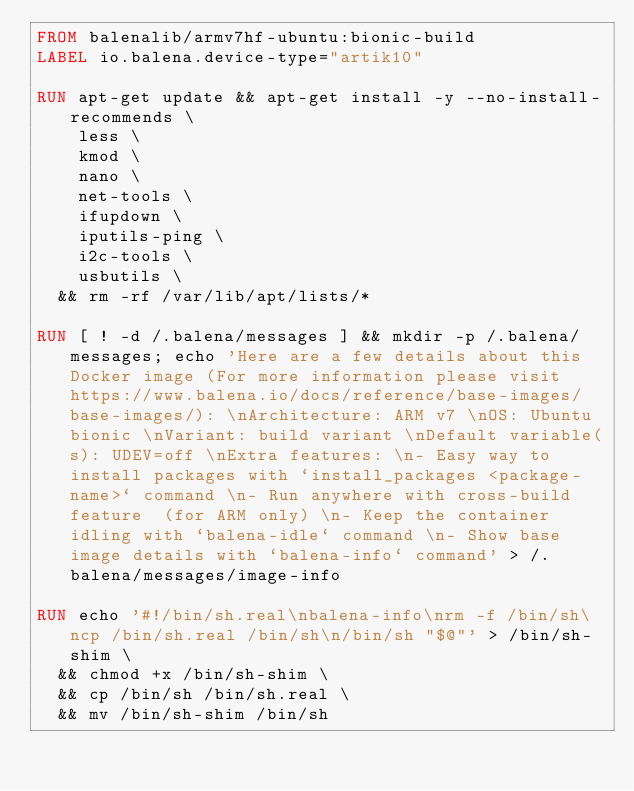Convert code to text. <code><loc_0><loc_0><loc_500><loc_500><_Dockerfile_>FROM balenalib/armv7hf-ubuntu:bionic-build
LABEL io.balena.device-type="artik10"

RUN apt-get update && apt-get install -y --no-install-recommends \
		less \
		kmod \
		nano \
		net-tools \
		ifupdown \
		iputils-ping \
		i2c-tools \
		usbutils \
	&& rm -rf /var/lib/apt/lists/*

RUN [ ! -d /.balena/messages ] && mkdir -p /.balena/messages; echo 'Here are a few details about this Docker image (For more information please visit https://www.balena.io/docs/reference/base-images/base-images/): \nArchitecture: ARM v7 \nOS: Ubuntu bionic \nVariant: build variant \nDefault variable(s): UDEV=off \nExtra features: \n- Easy way to install packages with `install_packages <package-name>` command \n- Run anywhere with cross-build feature  (for ARM only) \n- Keep the container idling with `balena-idle` command \n- Show base image details with `balena-info` command' > /.balena/messages/image-info

RUN echo '#!/bin/sh.real\nbalena-info\nrm -f /bin/sh\ncp /bin/sh.real /bin/sh\n/bin/sh "$@"' > /bin/sh-shim \
	&& chmod +x /bin/sh-shim \
	&& cp /bin/sh /bin/sh.real \
	&& mv /bin/sh-shim /bin/sh</code> 